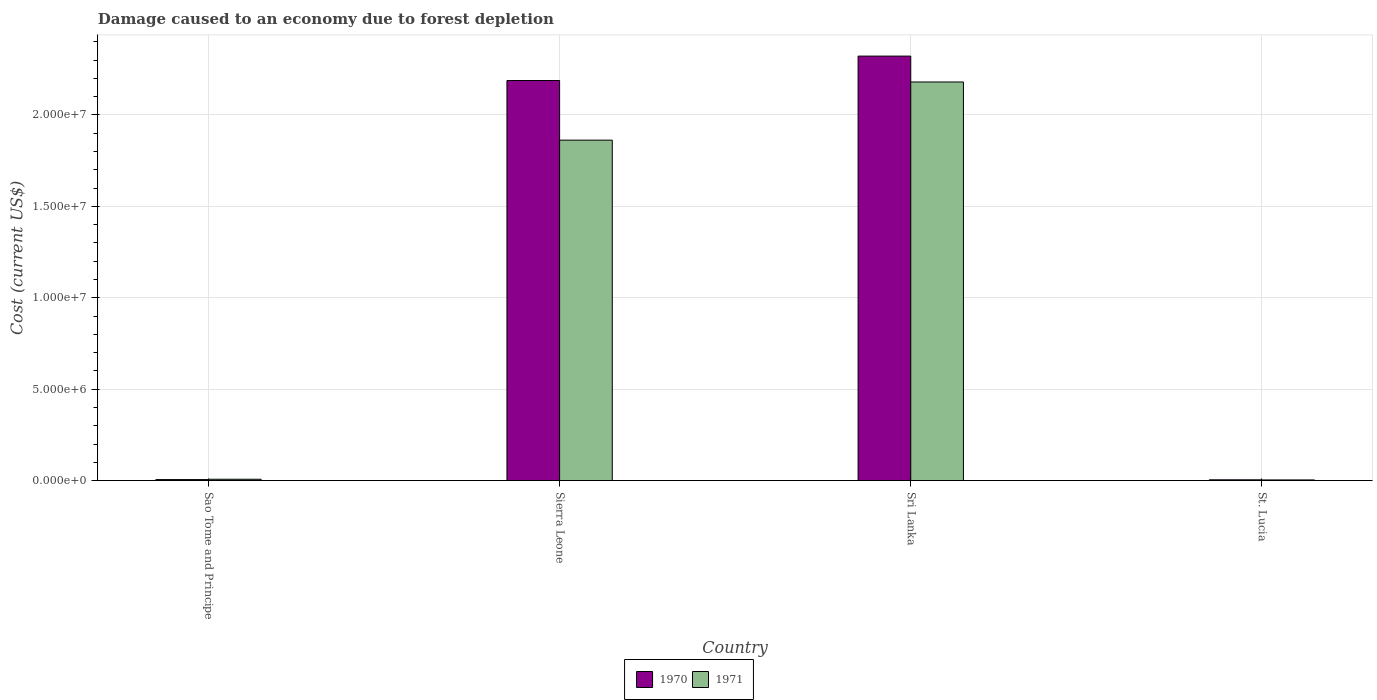How many different coloured bars are there?
Make the answer very short. 2. How many groups of bars are there?
Offer a terse response. 4. Are the number of bars on each tick of the X-axis equal?
Provide a succinct answer. Yes. How many bars are there on the 2nd tick from the left?
Provide a succinct answer. 2. How many bars are there on the 3rd tick from the right?
Make the answer very short. 2. What is the label of the 3rd group of bars from the left?
Offer a terse response. Sri Lanka. What is the cost of damage caused due to forest depletion in 1971 in St. Lucia?
Ensure brevity in your answer.  3.58e+04. Across all countries, what is the maximum cost of damage caused due to forest depletion in 1971?
Keep it short and to the point. 2.18e+07. Across all countries, what is the minimum cost of damage caused due to forest depletion in 1971?
Your response must be concise. 3.58e+04. In which country was the cost of damage caused due to forest depletion in 1971 maximum?
Ensure brevity in your answer.  Sri Lanka. In which country was the cost of damage caused due to forest depletion in 1971 minimum?
Keep it short and to the point. St. Lucia. What is the total cost of damage caused due to forest depletion in 1971 in the graph?
Offer a terse response. 4.05e+07. What is the difference between the cost of damage caused due to forest depletion in 1971 in Sri Lanka and that in St. Lucia?
Ensure brevity in your answer.  2.18e+07. What is the difference between the cost of damage caused due to forest depletion in 1971 in Sri Lanka and the cost of damage caused due to forest depletion in 1970 in Sao Tome and Principe?
Your answer should be compact. 2.17e+07. What is the average cost of damage caused due to forest depletion in 1971 per country?
Keep it short and to the point. 1.01e+07. What is the difference between the cost of damage caused due to forest depletion of/in 1971 and cost of damage caused due to forest depletion of/in 1970 in St. Lucia?
Offer a very short reply. -5318.94. What is the ratio of the cost of damage caused due to forest depletion in 1971 in Sierra Leone to that in St. Lucia?
Your response must be concise. 520.23. Is the difference between the cost of damage caused due to forest depletion in 1971 in Sri Lanka and St. Lucia greater than the difference between the cost of damage caused due to forest depletion in 1970 in Sri Lanka and St. Lucia?
Make the answer very short. No. What is the difference between the highest and the second highest cost of damage caused due to forest depletion in 1971?
Make the answer very short. -2.17e+07. What is the difference between the highest and the lowest cost of damage caused due to forest depletion in 1970?
Provide a short and direct response. 2.32e+07. In how many countries, is the cost of damage caused due to forest depletion in 1970 greater than the average cost of damage caused due to forest depletion in 1970 taken over all countries?
Offer a very short reply. 2. Is the sum of the cost of damage caused due to forest depletion in 1971 in Sri Lanka and St. Lucia greater than the maximum cost of damage caused due to forest depletion in 1970 across all countries?
Provide a short and direct response. No. What does the 1st bar from the left in Sri Lanka represents?
Keep it short and to the point. 1970. What does the 2nd bar from the right in Sao Tome and Principe represents?
Provide a short and direct response. 1970. Are all the bars in the graph horizontal?
Make the answer very short. No. How many countries are there in the graph?
Offer a very short reply. 4. How are the legend labels stacked?
Your answer should be very brief. Horizontal. What is the title of the graph?
Give a very brief answer. Damage caused to an economy due to forest depletion. Does "2010" appear as one of the legend labels in the graph?
Give a very brief answer. No. What is the label or title of the X-axis?
Make the answer very short. Country. What is the label or title of the Y-axis?
Offer a very short reply. Cost (current US$). What is the Cost (current US$) of 1970 in Sao Tome and Principe?
Your answer should be very brief. 5.31e+04. What is the Cost (current US$) of 1971 in Sao Tome and Principe?
Your response must be concise. 7.23e+04. What is the Cost (current US$) in 1970 in Sierra Leone?
Your answer should be very brief. 2.19e+07. What is the Cost (current US$) in 1971 in Sierra Leone?
Offer a very short reply. 1.86e+07. What is the Cost (current US$) in 1970 in Sri Lanka?
Your response must be concise. 2.32e+07. What is the Cost (current US$) in 1971 in Sri Lanka?
Provide a short and direct response. 2.18e+07. What is the Cost (current US$) of 1970 in St. Lucia?
Offer a very short reply. 4.11e+04. What is the Cost (current US$) in 1971 in St. Lucia?
Give a very brief answer. 3.58e+04. Across all countries, what is the maximum Cost (current US$) in 1970?
Your answer should be very brief. 2.32e+07. Across all countries, what is the maximum Cost (current US$) in 1971?
Provide a short and direct response. 2.18e+07. Across all countries, what is the minimum Cost (current US$) in 1970?
Your answer should be compact. 4.11e+04. Across all countries, what is the minimum Cost (current US$) of 1971?
Keep it short and to the point. 3.58e+04. What is the total Cost (current US$) in 1970 in the graph?
Offer a terse response. 4.52e+07. What is the total Cost (current US$) of 1971 in the graph?
Your answer should be very brief. 4.05e+07. What is the difference between the Cost (current US$) of 1970 in Sao Tome and Principe and that in Sierra Leone?
Offer a very short reply. -2.18e+07. What is the difference between the Cost (current US$) in 1971 in Sao Tome and Principe and that in Sierra Leone?
Provide a succinct answer. -1.85e+07. What is the difference between the Cost (current US$) of 1970 in Sao Tome and Principe and that in Sri Lanka?
Your response must be concise. -2.32e+07. What is the difference between the Cost (current US$) of 1971 in Sao Tome and Principe and that in Sri Lanka?
Your response must be concise. -2.17e+07. What is the difference between the Cost (current US$) in 1970 in Sao Tome and Principe and that in St. Lucia?
Your response must be concise. 1.20e+04. What is the difference between the Cost (current US$) in 1971 in Sao Tome and Principe and that in St. Lucia?
Give a very brief answer. 3.65e+04. What is the difference between the Cost (current US$) in 1970 in Sierra Leone and that in Sri Lanka?
Your response must be concise. -1.34e+06. What is the difference between the Cost (current US$) of 1971 in Sierra Leone and that in Sri Lanka?
Ensure brevity in your answer.  -3.18e+06. What is the difference between the Cost (current US$) in 1970 in Sierra Leone and that in St. Lucia?
Give a very brief answer. 2.18e+07. What is the difference between the Cost (current US$) in 1971 in Sierra Leone and that in St. Lucia?
Your response must be concise. 1.86e+07. What is the difference between the Cost (current US$) of 1970 in Sri Lanka and that in St. Lucia?
Your response must be concise. 2.32e+07. What is the difference between the Cost (current US$) of 1971 in Sri Lanka and that in St. Lucia?
Make the answer very short. 2.18e+07. What is the difference between the Cost (current US$) of 1970 in Sao Tome and Principe and the Cost (current US$) of 1971 in Sierra Leone?
Give a very brief answer. -1.86e+07. What is the difference between the Cost (current US$) of 1970 in Sao Tome and Principe and the Cost (current US$) of 1971 in Sri Lanka?
Provide a succinct answer. -2.17e+07. What is the difference between the Cost (current US$) of 1970 in Sao Tome and Principe and the Cost (current US$) of 1971 in St. Lucia?
Ensure brevity in your answer.  1.73e+04. What is the difference between the Cost (current US$) in 1970 in Sierra Leone and the Cost (current US$) in 1971 in Sri Lanka?
Give a very brief answer. 8.01e+04. What is the difference between the Cost (current US$) in 1970 in Sierra Leone and the Cost (current US$) in 1971 in St. Lucia?
Your response must be concise. 2.18e+07. What is the difference between the Cost (current US$) in 1970 in Sri Lanka and the Cost (current US$) in 1971 in St. Lucia?
Keep it short and to the point. 2.32e+07. What is the average Cost (current US$) of 1970 per country?
Ensure brevity in your answer.  1.13e+07. What is the average Cost (current US$) in 1971 per country?
Provide a succinct answer. 1.01e+07. What is the difference between the Cost (current US$) in 1970 and Cost (current US$) in 1971 in Sao Tome and Principe?
Make the answer very short. -1.92e+04. What is the difference between the Cost (current US$) in 1970 and Cost (current US$) in 1971 in Sierra Leone?
Provide a short and direct response. 3.26e+06. What is the difference between the Cost (current US$) in 1970 and Cost (current US$) in 1971 in Sri Lanka?
Offer a terse response. 1.42e+06. What is the difference between the Cost (current US$) of 1970 and Cost (current US$) of 1971 in St. Lucia?
Your answer should be very brief. 5318.94. What is the ratio of the Cost (current US$) of 1970 in Sao Tome and Principe to that in Sierra Leone?
Provide a short and direct response. 0. What is the ratio of the Cost (current US$) of 1971 in Sao Tome and Principe to that in Sierra Leone?
Give a very brief answer. 0. What is the ratio of the Cost (current US$) in 1970 in Sao Tome and Principe to that in Sri Lanka?
Your answer should be compact. 0. What is the ratio of the Cost (current US$) in 1971 in Sao Tome and Principe to that in Sri Lanka?
Make the answer very short. 0. What is the ratio of the Cost (current US$) of 1970 in Sao Tome and Principe to that in St. Lucia?
Your response must be concise. 1.29. What is the ratio of the Cost (current US$) in 1971 in Sao Tome and Principe to that in St. Lucia?
Provide a succinct answer. 2.02. What is the ratio of the Cost (current US$) of 1970 in Sierra Leone to that in Sri Lanka?
Provide a succinct answer. 0.94. What is the ratio of the Cost (current US$) in 1971 in Sierra Leone to that in Sri Lanka?
Offer a very short reply. 0.85. What is the ratio of the Cost (current US$) of 1970 in Sierra Leone to that in St. Lucia?
Your answer should be very brief. 532.27. What is the ratio of the Cost (current US$) of 1971 in Sierra Leone to that in St. Lucia?
Keep it short and to the point. 520.23. What is the ratio of the Cost (current US$) of 1970 in Sri Lanka to that in St. Lucia?
Offer a very short reply. 564.74. What is the ratio of the Cost (current US$) in 1971 in Sri Lanka to that in St. Lucia?
Provide a succinct answer. 609.13. What is the difference between the highest and the second highest Cost (current US$) in 1970?
Your answer should be compact. 1.34e+06. What is the difference between the highest and the second highest Cost (current US$) of 1971?
Your response must be concise. 3.18e+06. What is the difference between the highest and the lowest Cost (current US$) of 1970?
Provide a short and direct response. 2.32e+07. What is the difference between the highest and the lowest Cost (current US$) of 1971?
Provide a short and direct response. 2.18e+07. 